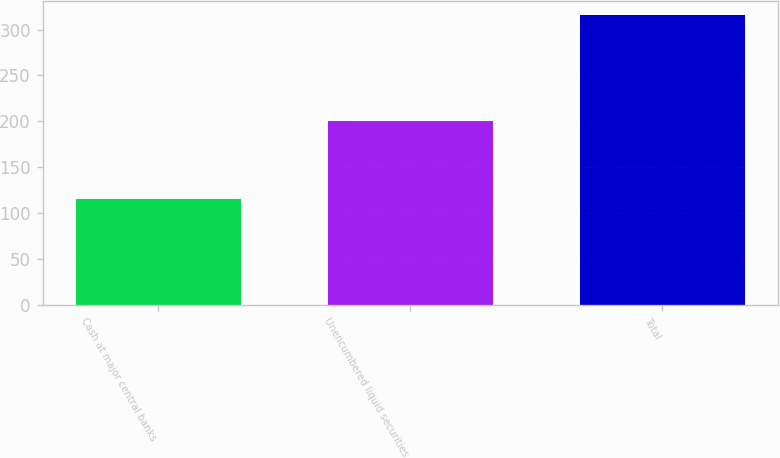Convert chart. <chart><loc_0><loc_0><loc_500><loc_500><bar_chart><fcel>Cash at major central banks<fcel>Unencumbered liquid securities<fcel>Total<nl><fcel>115.5<fcel>200<fcel>315.5<nl></chart> 